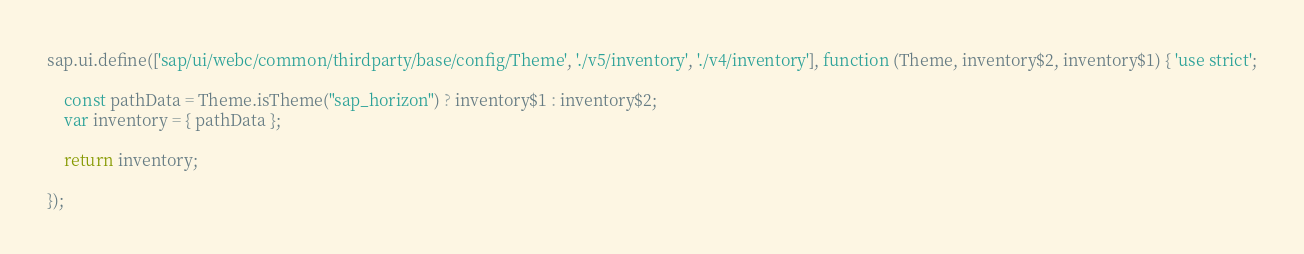<code> <loc_0><loc_0><loc_500><loc_500><_JavaScript_>sap.ui.define(['sap/ui/webc/common/thirdparty/base/config/Theme', './v5/inventory', './v4/inventory'], function (Theme, inventory$2, inventory$1) { 'use strict';

	const pathData = Theme.isTheme("sap_horizon") ? inventory$1 : inventory$2;
	var inventory = { pathData };

	return inventory;

});
</code> 